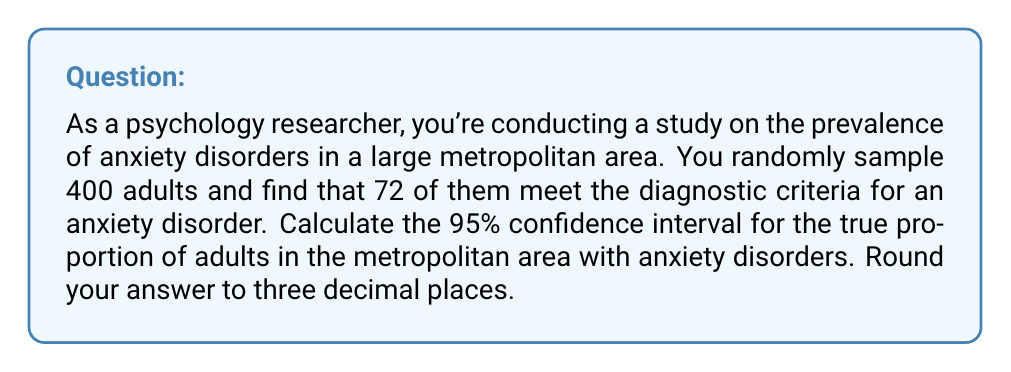Could you help me with this problem? To calculate the confidence interval for a population proportion, we'll use the formula:

$$ p \pm z \sqrt{\frac{p(1-p)}{n}} $$

Where:
$p$ = sample proportion
$z$ = z-score for the desired confidence level
$n$ = sample size

Step 1: Calculate the sample proportion (p)
$p = \frac{72}{400} = 0.18$

Step 2: Determine the z-score for a 95% confidence interval
For a 95% confidence interval, z = 1.96

Step 3: Calculate the margin of error
$$ \text{Margin of Error} = 1.96 \sqrt{\frac{0.18(1-0.18)}{400}} $$
$$ = 1.96 \sqrt{\frac{0.1476}{400}} $$
$$ = 1.96 \sqrt{0.000369} $$
$$ = 1.96 \times 0.0192 $$
$$ = 0.03763 $$

Step 4: Calculate the confidence interval
Lower bound: $0.18 - 0.03763 = 0.14237$
Upper bound: $0.18 + 0.03763 = 0.21763$

Step 5: Round to three decimal places
Lower bound: 0.142
Upper bound: 0.218
Answer: The 95% confidence interval for the true proportion of adults with anxiety disorders in the metropolitan area is (0.142, 0.218) or 14.2% to 21.8%. 